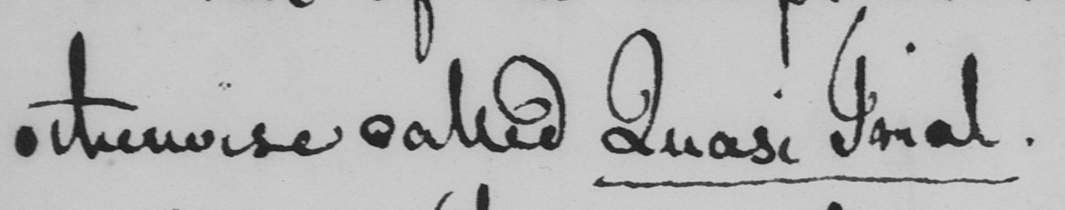Please transcribe the handwritten text in this image. otherwise called Quasi Trial . 